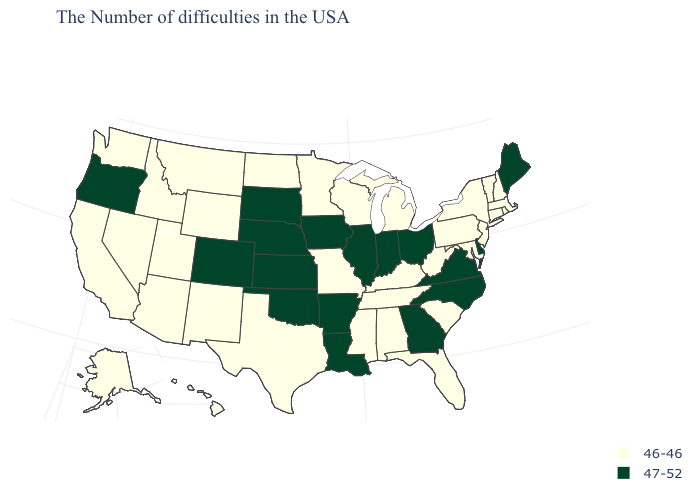What is the value of South Carolina?
Keep it brief. 46-46. What is the value of Louisiana?
Write a very short answer. 47-52. Which states have the lowest value in the USA?
Give a very brief answer. Massachusetts, Rhode Island, New Hampshire, Vermont, Connecticut, New York, New Jersey, Maryland, Pennsylvania, South Carolina, West Virginia, Florida, Michigan, Kentucky, Alabama, Tennessee, Wisconsin, Mississippi, Missouri, Minnesota, Texas, North Dakota, Wyoming, New Mexico, Utah, Montana, Arizona, Idaho, Nevada, California, Washington, Alaska, Hawaii. What is the highest value in the MidWest ?
Be succinct. 47-52. What is the lowest value in the South?
Write a very short answer. 46-46. What is the value of Florida?
Answer briefly. 46-46. Among the states that border Arkansas , does Oklahoma have the highest value?
Short answer required. Yes. Is the legend a continuous bar?
Write a very short answer. No. Does New Hampshire have the lowest value in the USA?
Give a very brief answer. Yes. What is the highest value in the West ?
Be succinct. 47-52. Which states have the lowest value in the USA?
Concise answer only. Massachusetts, Rhode Island, New Hampshire, Vermont, Connecticut, New York, New Jersey, Maryland, Pennsylvania, South Carolina, West Virginia, Florida, Michigan, Kentucky, Alabama, Tennessee, Wisconsin, Mississippi, Missouri, Minnesota, Texas, North Dakota, Wyoming, New Mexico, Utah, Montana, Arizona, Idaho, Nevada, California, Washington, Alaska, Hawaii. What is the value of Idaho?
Be succinct. 46-46. Name the states that have a value in the range 47-52?
Keep it brief. Maine, Delaware, Virginia, North Carolina, Ohio, Georgia, Indiana, Illinois, Louisiana, Arkansas, Iowa, Kansas, Nebraska, Oklahoma, South Dakota, Colorado, Oregon. What is the lowest value in states that border Minnesota?
Keep it brief. 46-46. Does Indiana have the same value as Arkansas?
Quick response, please. Yes. 